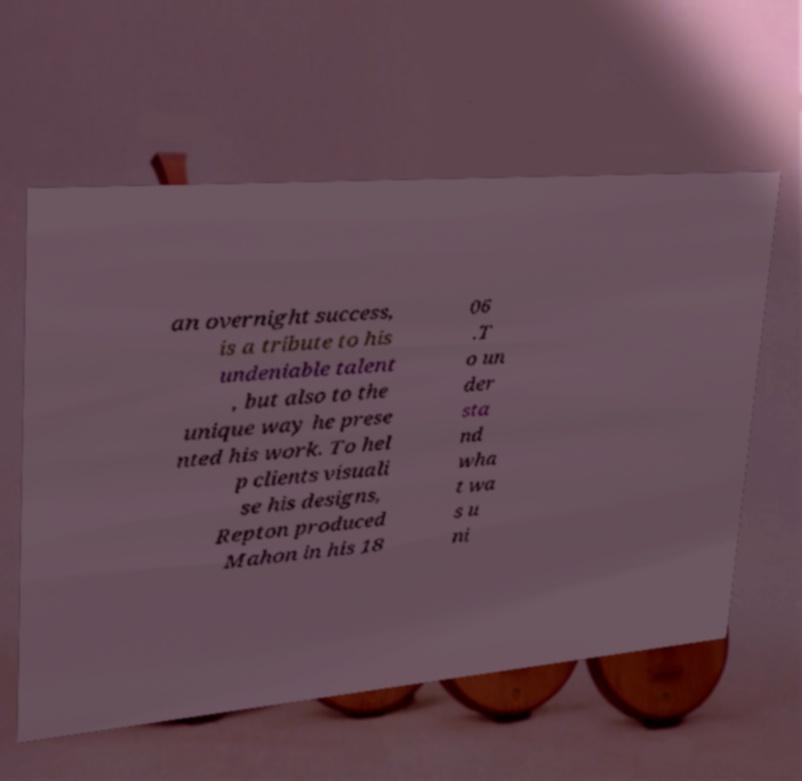Could you assist in decoding the text presented in this image and type it out clearly? an overnight success, is a tribute to his undeniable talent , but also to the unique way he prese nted his work. To hel p clients visuali se his designs, Repton produced Mahon in his 18 06 .T o un der sta nd wha t wa s u ni 